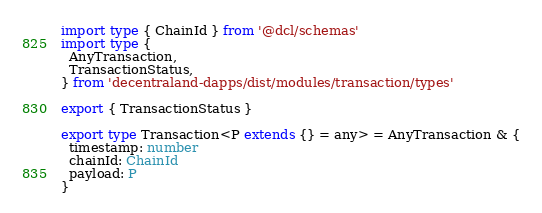Convert code to text. <code><loc_0><loc_0><loc_500><loc_500><_TypeScript_>import type { ChainId } from '@dcl/schemas'
import type {
  AnyTransaction,
  TransactionStatus,
} from 'decentraland-dapps/dist/modules/transaction/types'

export { TransactionStatus }

export type Transaction<P extends {} = any> = AnyTransaction & {
  timestamp: number
  chainId: ChainId
  payload: P
}
</code> 